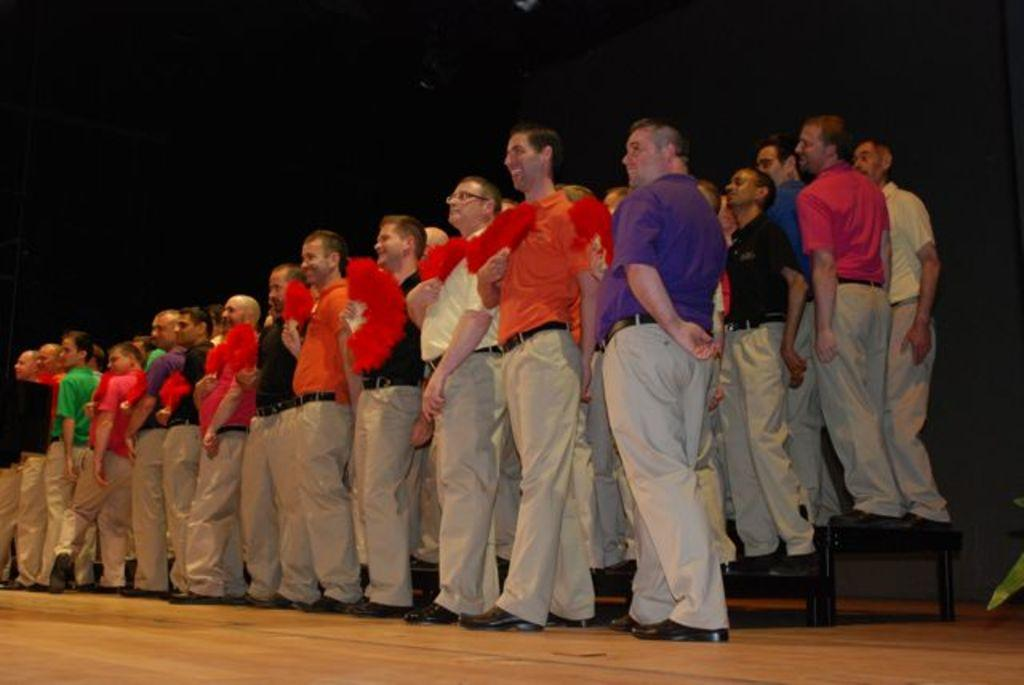How many people are in the image? There is a group of people in the image. What are some of the people doing in the image? Some people are standing on stands, and some people are holding objects. What can be seen on the right side of the image? There are leaves visible on the right side of the image. Can you tell me how many donkeys are present in the image? There are no donkeys present in the image. What type of curve can be seen in the image? There is no curve visible in the image. 